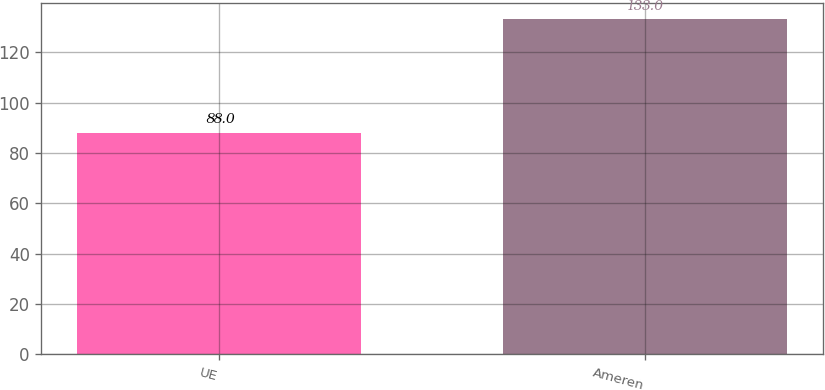Convert chart. <chart><loc_0><loc_0><loc_500><loc_500><bar_chart><fcel>UE<fcel>Ameren<nl><fcel>88<fcel>133<nl></chart> 